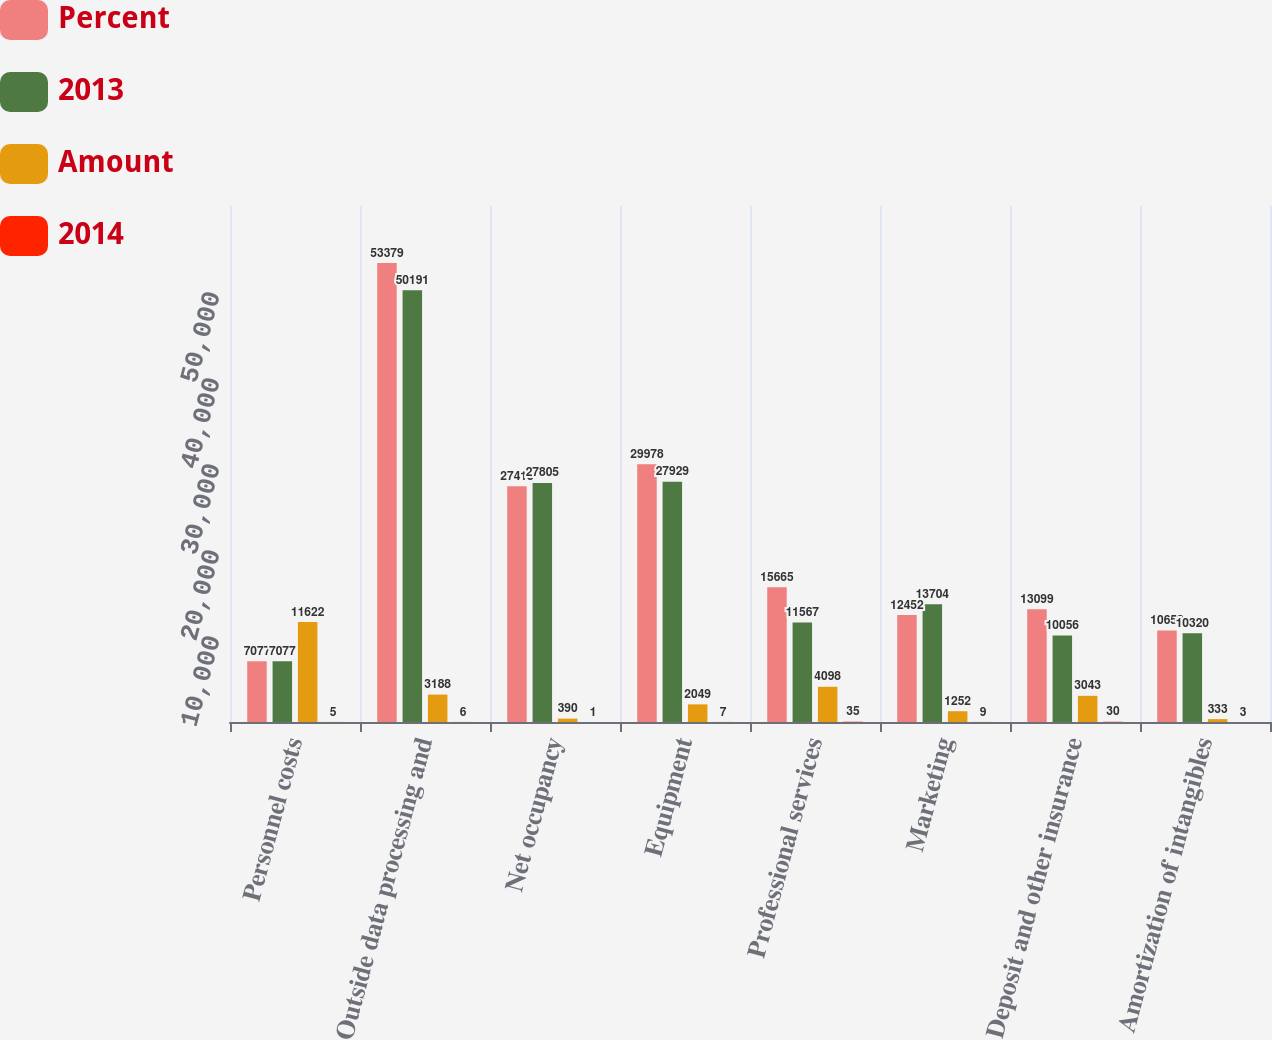Convert chart. <chart><loc_0><loc_0><loc_500><loc_500><stacked_bar_chart><ecel><fcel>Personnel costs<fcel>Outside data processing and<fcel>Net occupancy<fcel>Equipment<fcel>Professional services<fcel>Marketing<fcel>Deposit and other insurance<fcel>Amortization of intangibles<nl><fcel>Percent<fcel>7077<fcel>53379<fcel>27415<fcel>29978<fcel>15665<fcel>12452<fcel>13099<fcel>10653<nl><fcel>2013<fcel>7077<fcel>50191<fcel>27805<fcel>27929<fcel>11567<fcel>13704<fcel>10056<fcel>10320<nl><fcel>Amount<fcel>11622<fcel>3188<fcel>390<fcel>2049<fcel>4098<fcel>1252<fcel>3043<fcel>333<nl><fcel>2014<fcel>5<fcel>6<fcel>1<fcel>7<fcel>35<fcel>9<fcel>30<fcel>3<nl></chart> 